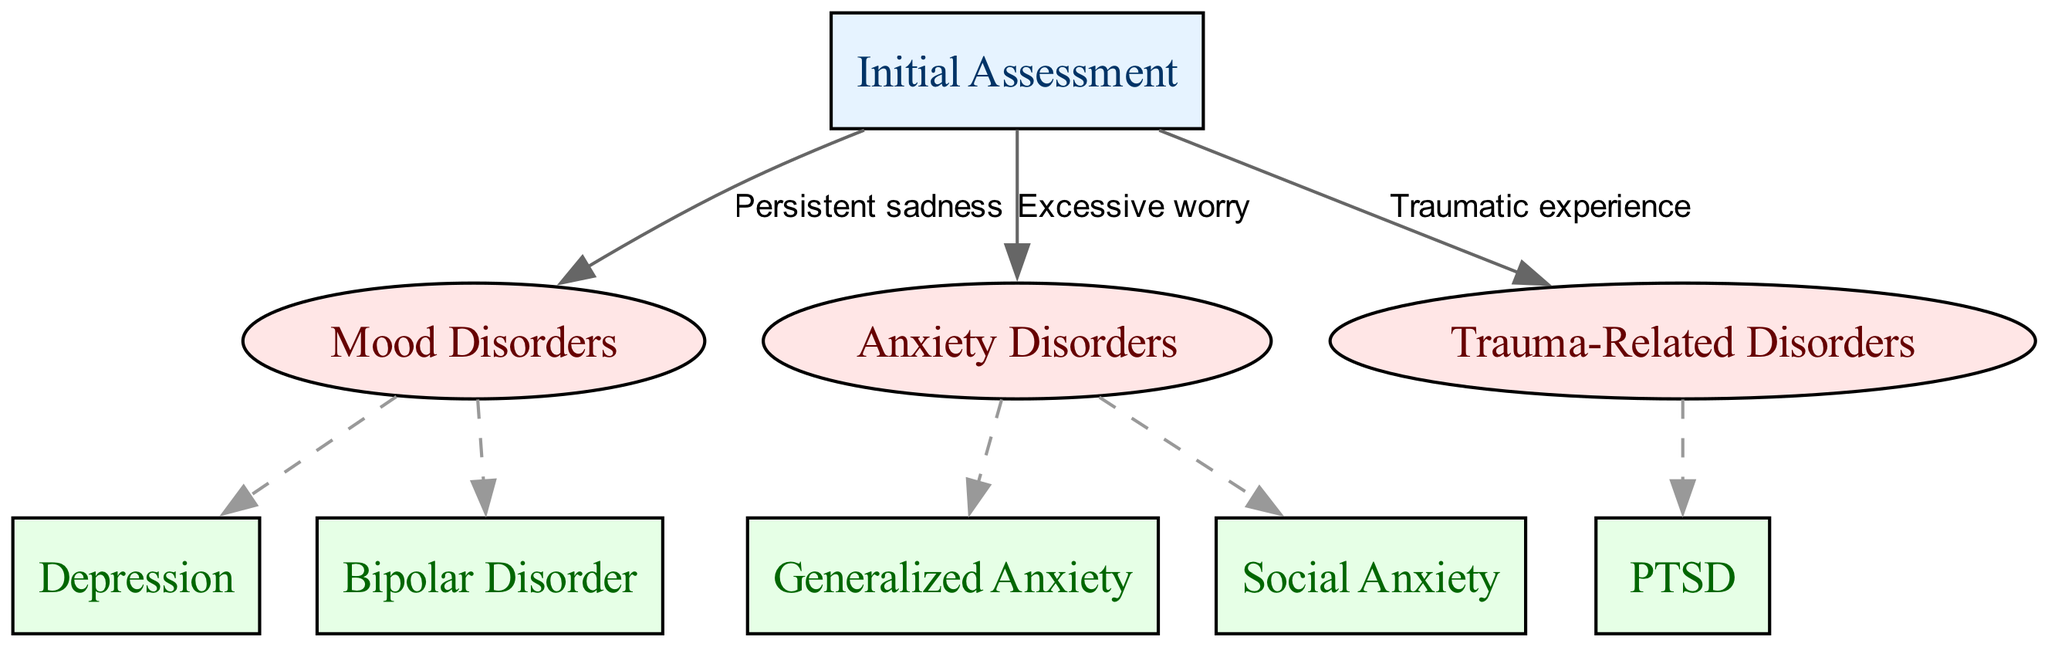What is the root node of the diagram? The diagram starts with the "Initial Assessment" node as the root. This is the first step in the diagnostic process before moving to specific disorders.
Answer: Initial Assessment How many main categories are there in the diagram? The diagram includes three main categories: Mood Disorders, Anxiety Disorders, and Trauma-Related Disorders, which are all directly connected to the root.
Answer: Three Which disorder is associated with "Persistent sadness"? The edge connected to Mood Disorders indicates that "Persistent sadness" leads to either Depression or Bipolar Disorder, but specifically targeting the primary disorder leads us to Depression.
Answer: Depression What type of disorder is associated with "Excessive worry"? The edge indicates that "Excessive worry" is specifically linked to Anxiety Disorders, narrowing it down to either Generalized Anxiety or Social Anxiety.
Answer: Anxiety Disorders How many total child nodes exist under all categories? Each main category has the following child nodes: Mood Disorders has 2 (Depression, Bipolar Disorder), Anxiety Disorders has 2 (Generalized Anxiety, Social Anxiety), and Trauma-Related Disorders has 1 (PTSD). Adding these together gives a total of 5 child nodes across all categories.
Answer: Five If someone experiences a "Traumatic experience," which specific disorder do they potentially have? The edge labeled "Traumatic experience" leads directly to the Trauma-Related Disorders category, specifically indicating the potential disorder as PTSD.
Answer: PTSD What is the relationship between the root node and the Anxiety Disorders node? The root node "Initial Assessment" is connected to the Anxiety Disorders node via the edge labeled "Excessive worry," showing that this type of worry is a direct reason for assessing anxiety.
Answer: Excessive worry Which node has a child node labeled "PTSD"? The Trauma-Related Disorders node has a child node labeled "PTSD," indicating it is the only disorder classified under this category.
Answer: Trauma-Related Disorders What color are the nodes representing main categories? The main category nodes are colored in a filled format with #FFE6E6, which gives them a light red appearance in the diagram.
Answer: Light red 